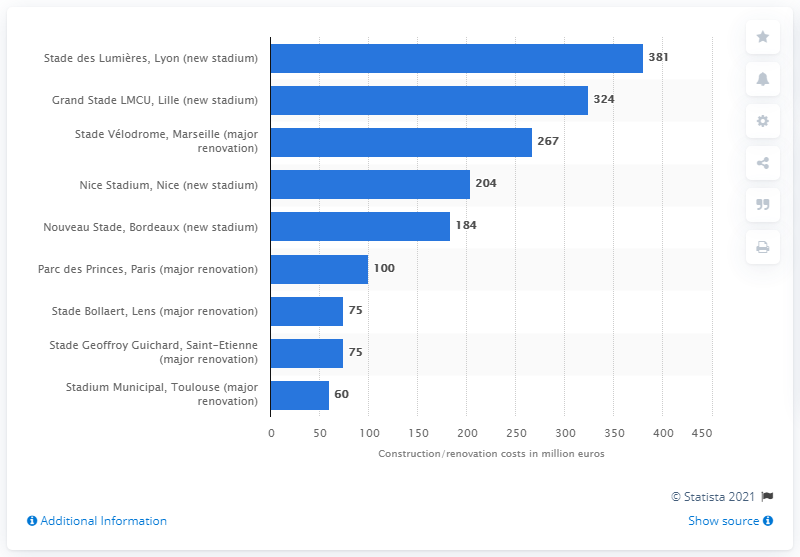Give some essential details in this illustration. The renovation of the Parc des Princes stadium is expected to cost approximately 100... 